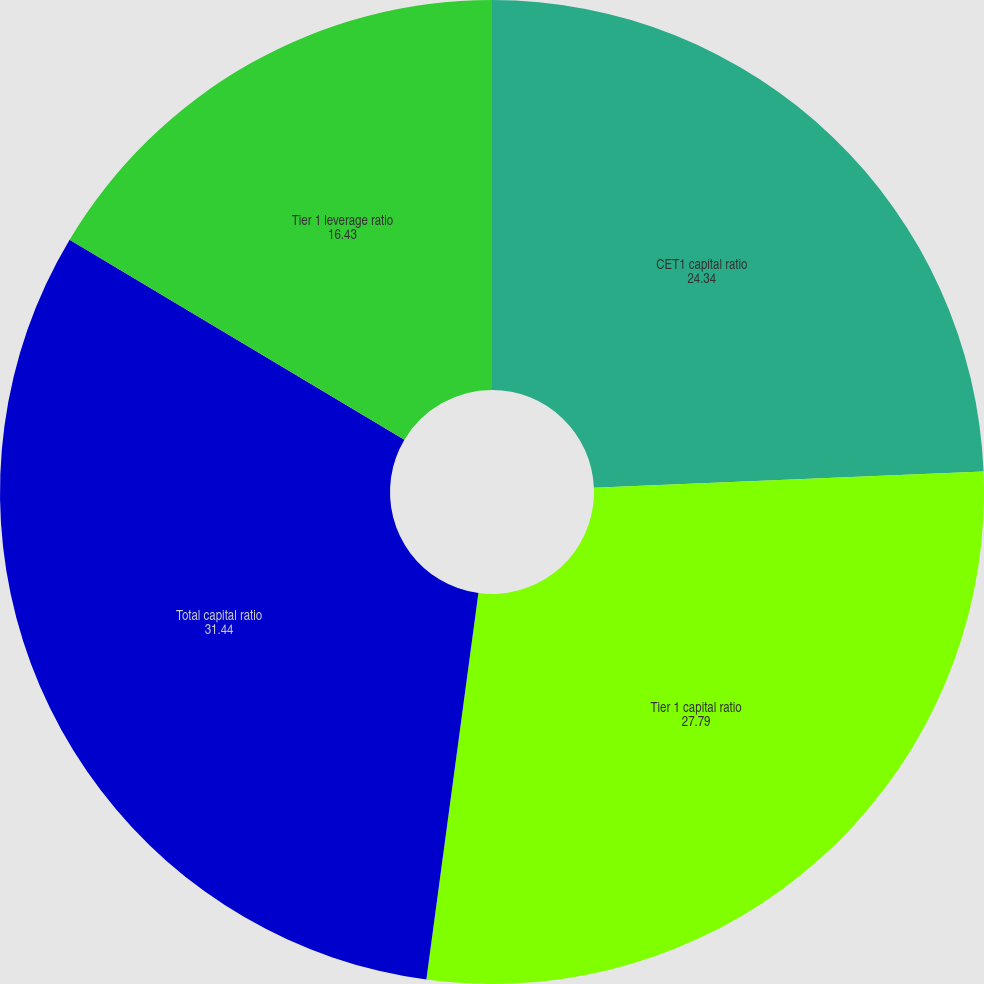<chart> <loc_0><loc_0><loc_500><loc_500><pie_chart><fcel>CET1 capital ratio<fcel>Tier 1 capital ratio<fcel>Total capital ratio<fcel>Tier 1 leverage ratio<nl><fcel>24.34%<fcel>27.79%<fcel>31.44%<fcel>16.43%<nl></chart> 